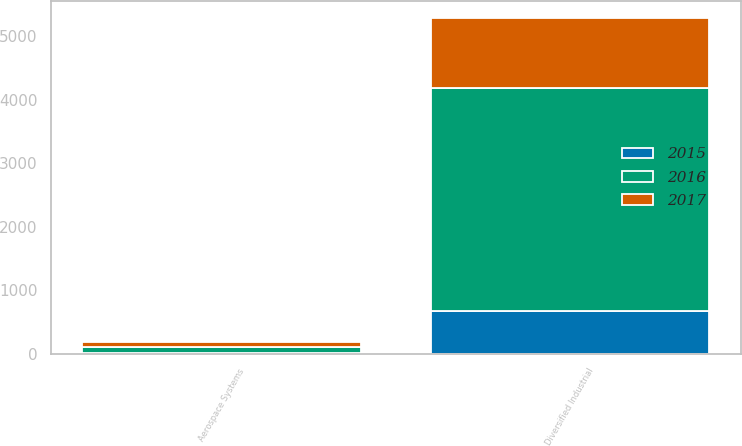Convert chart to OTSL. <chart><loc_0><loc_0><loc_500><loc_500><stacked_bar_chart><ecel><fcel>Diversified Industrial<fcel>Aerospace Systems<nl><fcel>2017<fcel>1102<fcel>89<nl><fcel>2016<fcel>3515<fcel>81<nl><fcel>2015<fcel>668<fcel>21<nl></chart> 